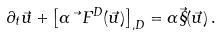Convert formula to latex. <formula><loc_0><loc_0><loc_500><loc_500>\partial _ { t } \vec { u } + \left [ \alpha \vec { \ } F ^ { D } ( \vec { u } ) \right ] _ { , D } = \alpha \vec { \S } ( \vec { u } ) \, .</formula> 